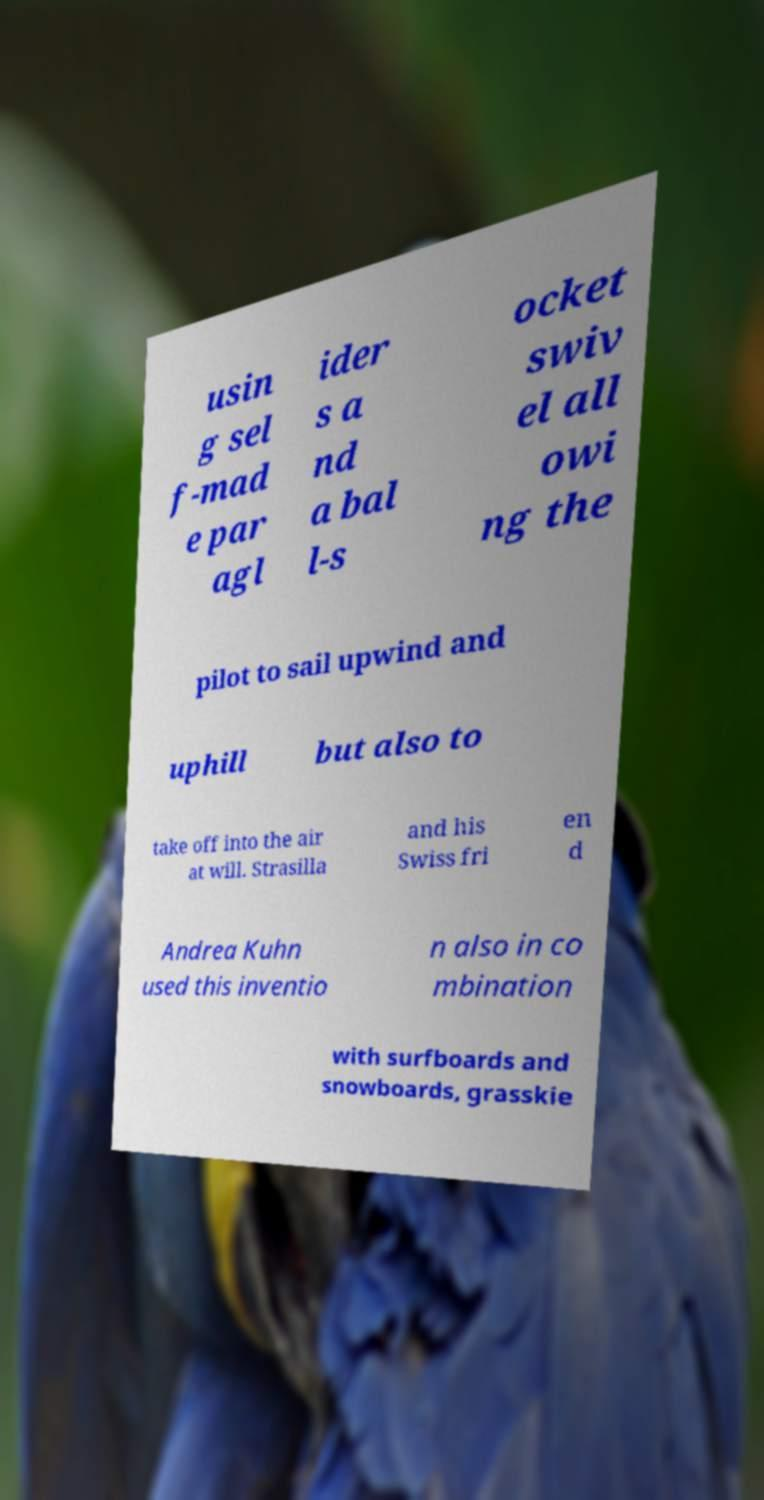What messages or text are displayed in this image? I need them in a readable, typed format. usin g sel f-mad e par agl ider s a nd a bal l-s ocket swiv el all owi ng the pilot to sail upwind and uphill but also to take off into the air at will. Strasilla and his Swiss fri en d Andrea Kuhn used this inventio n also in co mbination with surfboards and snowboards, grasskie 